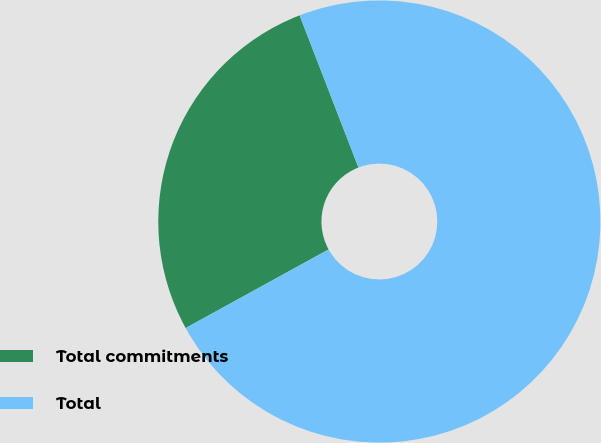Convert chart. <chart><loc_0><loc_0><loc_500><loc_500><pie_chart><fcel>Total commitments<fcel>Total<nl><fcel>27.13%<fcel>72.87%<nl></chart> 